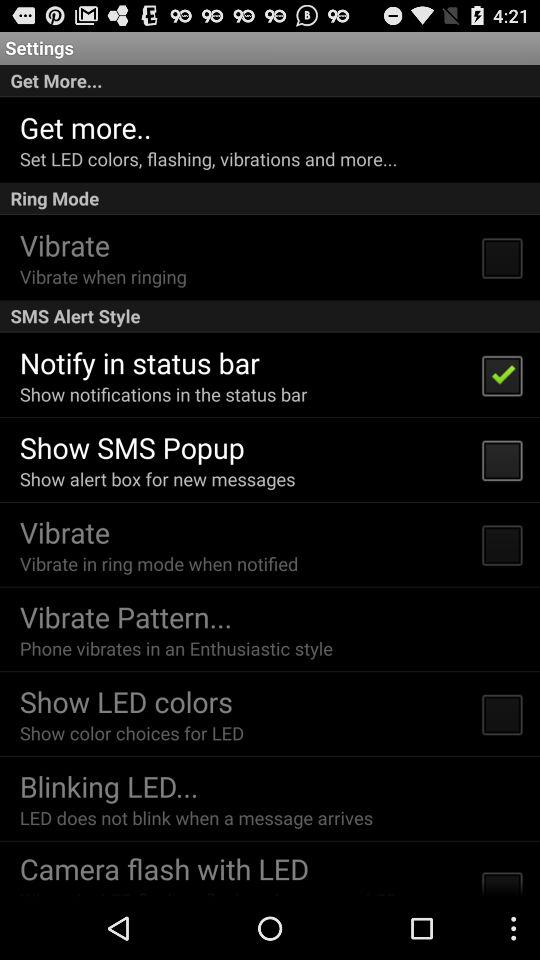What is the description of "Blinking LED"? The description of "Blinking LED" is "LED does not blink when a message arrives". 